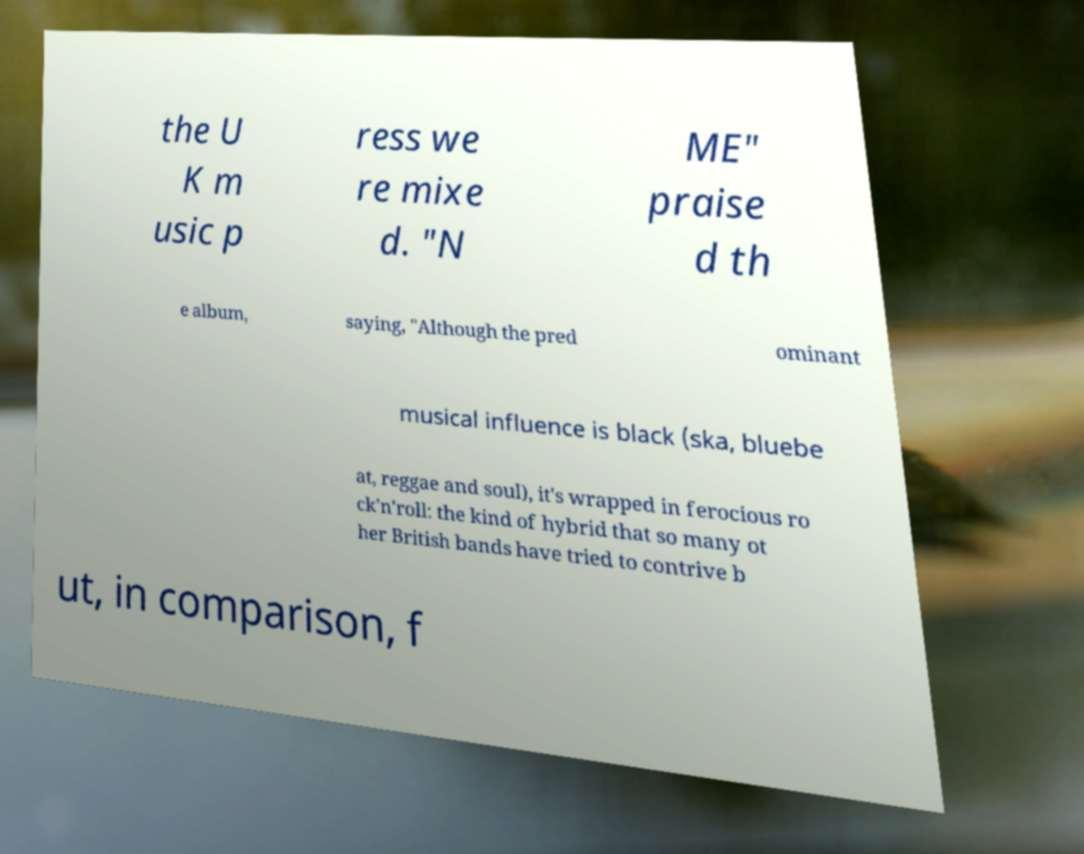Please read and relay the text visible in this image. What does it say? the U K m usic p ress we re mixe d. "N ME" praise d th e album, saying, "Although the pred ominant musical influence is black (ska, bluebe at, reggae and soul), it's wrapped in ferocious ro ck'n'roll: the kind of hybrid that so many ot her British bands have tried to contrive b ut, in comparison, f 